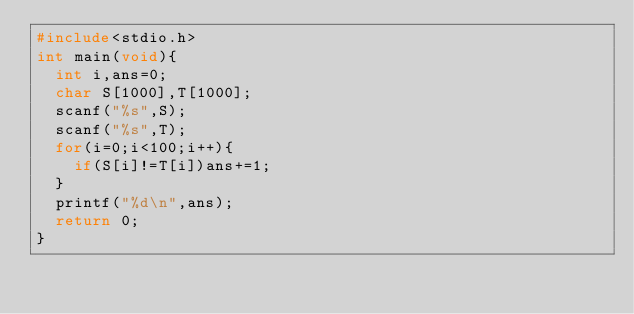<code> <loc_0><loc_0><loc_500><loc_500><_C_>#include<stdio.h>
int main(void){
  int i,ans=0;
  char S[1000],T[1000];
  scanf("%s",S);
  scanf("%s",T);
  for(i=0;i<100;i++){
    if(S[i]!=T[i])ans+=1;
  }
  printf("%d\n",ans);
  return 0;
}</code> 